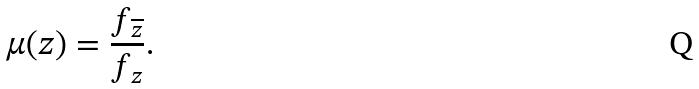<formula> <loc_0><loc_0><loc_500><loc_500>\mu ( z ) = \frac { f _ { \overline { z } } } { f _ { z } } .</formula> 